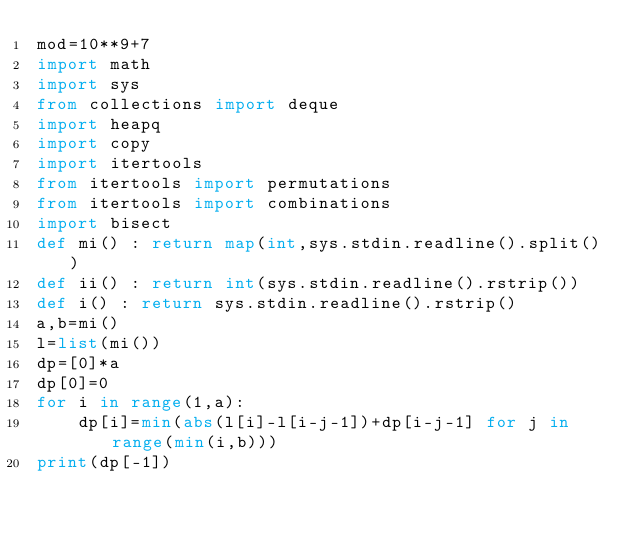Convert code to text. <code><loc_0><loc_0><loc_500><loc_500><_Python_>mod=10**9+7
import math
import sys
from collections import deque
import heapq
import copy
import itertools
from itertools import permutations
from itertools import combinations
import bisect
def mi() : return map(int,sys.stdin.readline().split())
def ii() : return int(sys.stdin.readline().rstrip())
def i() : return sys.stdin.readline().rstrip()
a,b=mi()
l=list(mi())
dp=[0]*a
dp[0]=0
for i in range(1,a):
    dp[i]=min(abs(l[i]-l[i-j-1])+dp[i-j-1] for j in range(min(i,b)))
print(dp[-1])</code> 